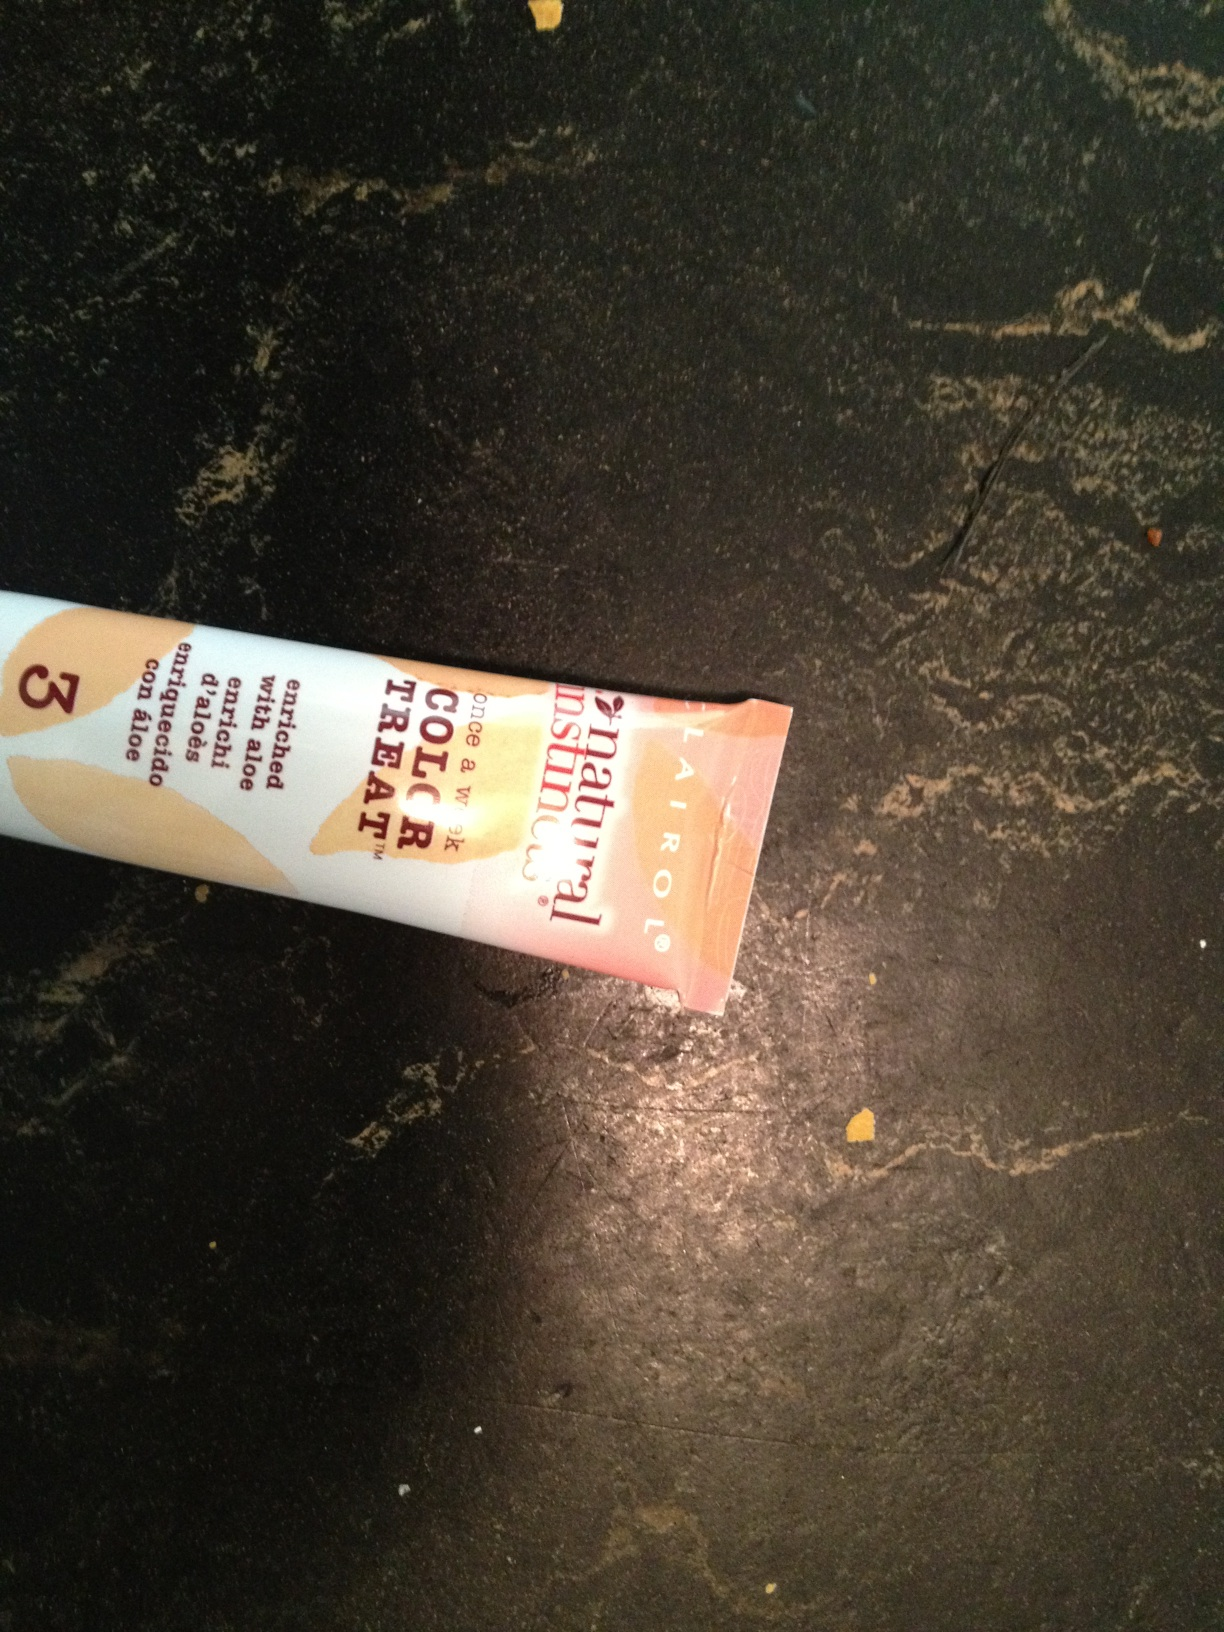Can you tell what brand this hair color treatment might be from the visible text? The brand name is not fully visible in the image, so I cannot provide the exact brand. However, the text suggests it could be a product focused on natural ingredients. Is there anything else you can tell about the product from the packaging? The packaging includes words like 'natural' and 'aloe,' hinting that the product is likely marketed as gentle or beneficial for the hair due to these natural additives. However, without a clear view of the whole package, other specific details cannot be determined. 